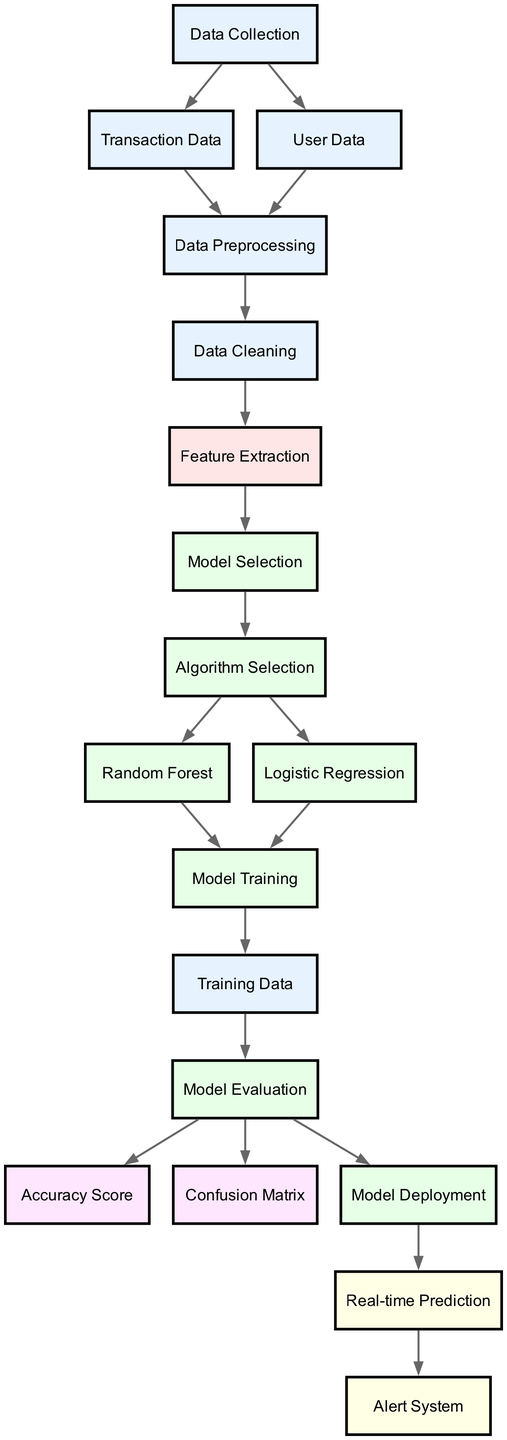What are the two main types of data collected in the system? The diagram shows two nodes coming from 'Data Collection': 'Transaction Data' and 'User Data'. This indicates that these are the two main types of data collected as input for the system.
Answer: Transaction Data, User Data How many nodes are present in the diagram? By counting each unique node listed in the data structure, we find there are a total of 17 nodes.
Answer: 17 What is the step that follows 'Data Cleaning'? The edge from 'Data Cleaning' leads directly to 'Feature Extraction', indicating that the next step in the process after cleaning the data is to extract features.
Answer: Feature Extraction Which algorithms are selected for model training? The diagram shows two nodes resulting from 'Algorithm Selection': 'Random Forest' and 'Logistic Regression'. These are the algorithms selected for training the model in the fraud detection process.
Answer: Random Forest, Logistic Regression What is the output of the 'Model Evaluation' step? The 'Model Evaluation' node connects to three distinct outputs: 'Accuracy Score', 'Confusion Matrix', and 'Model Deployment'. This indicates that the evaluation step results in these three outputs.
Answer: Accuracy Score, Confusion Matrix, Model Deployment What is the purpose of the 'Alert System'? The 'Alert System' is the final node which receives input from 'Real-time Prediction'. Thus, its purpose is to generate alerts based on the predictions made in real-time.
Answer: Generate alerts What follows 'Model Training' in the flow? The edge from 'Model Training' indicates that it leads to 'Training Data', which implies that the model is being trained with a certain dataset before evaluation.
Answer: Training Data Which step comes before 'Algorithm Selection'? Looking at the diagram, 'Model Selection' comes directly before 'Algorithm Selection', representing the steps leading to the choice of algorithm to use for model training.
Answer: Model Selection How many edges connect the nodes in the diagram? By inspecting the edges defined in the data structure, we see a total of 17 edges, which represent the connections between the various steps of the fraud detection system.
Answer: 17 